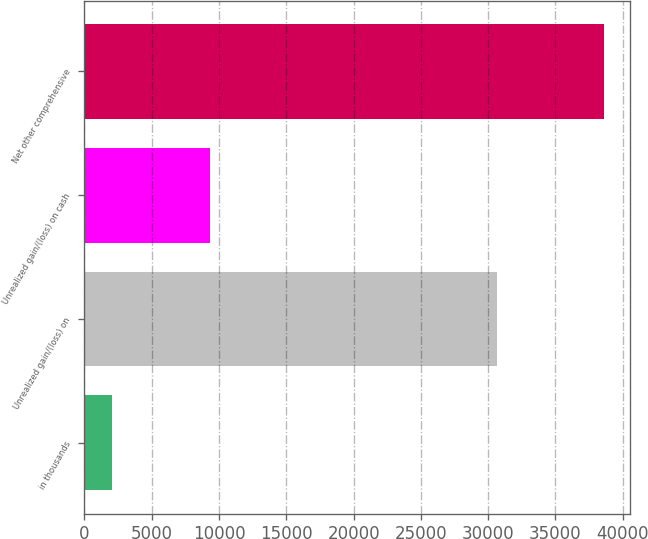Convert chart. <chart><loc_0><loc_0><loc_500><loc_500><bar_chart><fcel>in thousands<fcel>Unrealized gain/(loss) on<fcel>Unrealized gain/(loss) on cash<fcel>Net other comprehensive<nl><fcel>2015<fcel>30640<fcel>9335<fcel>38615<nl></chart> 